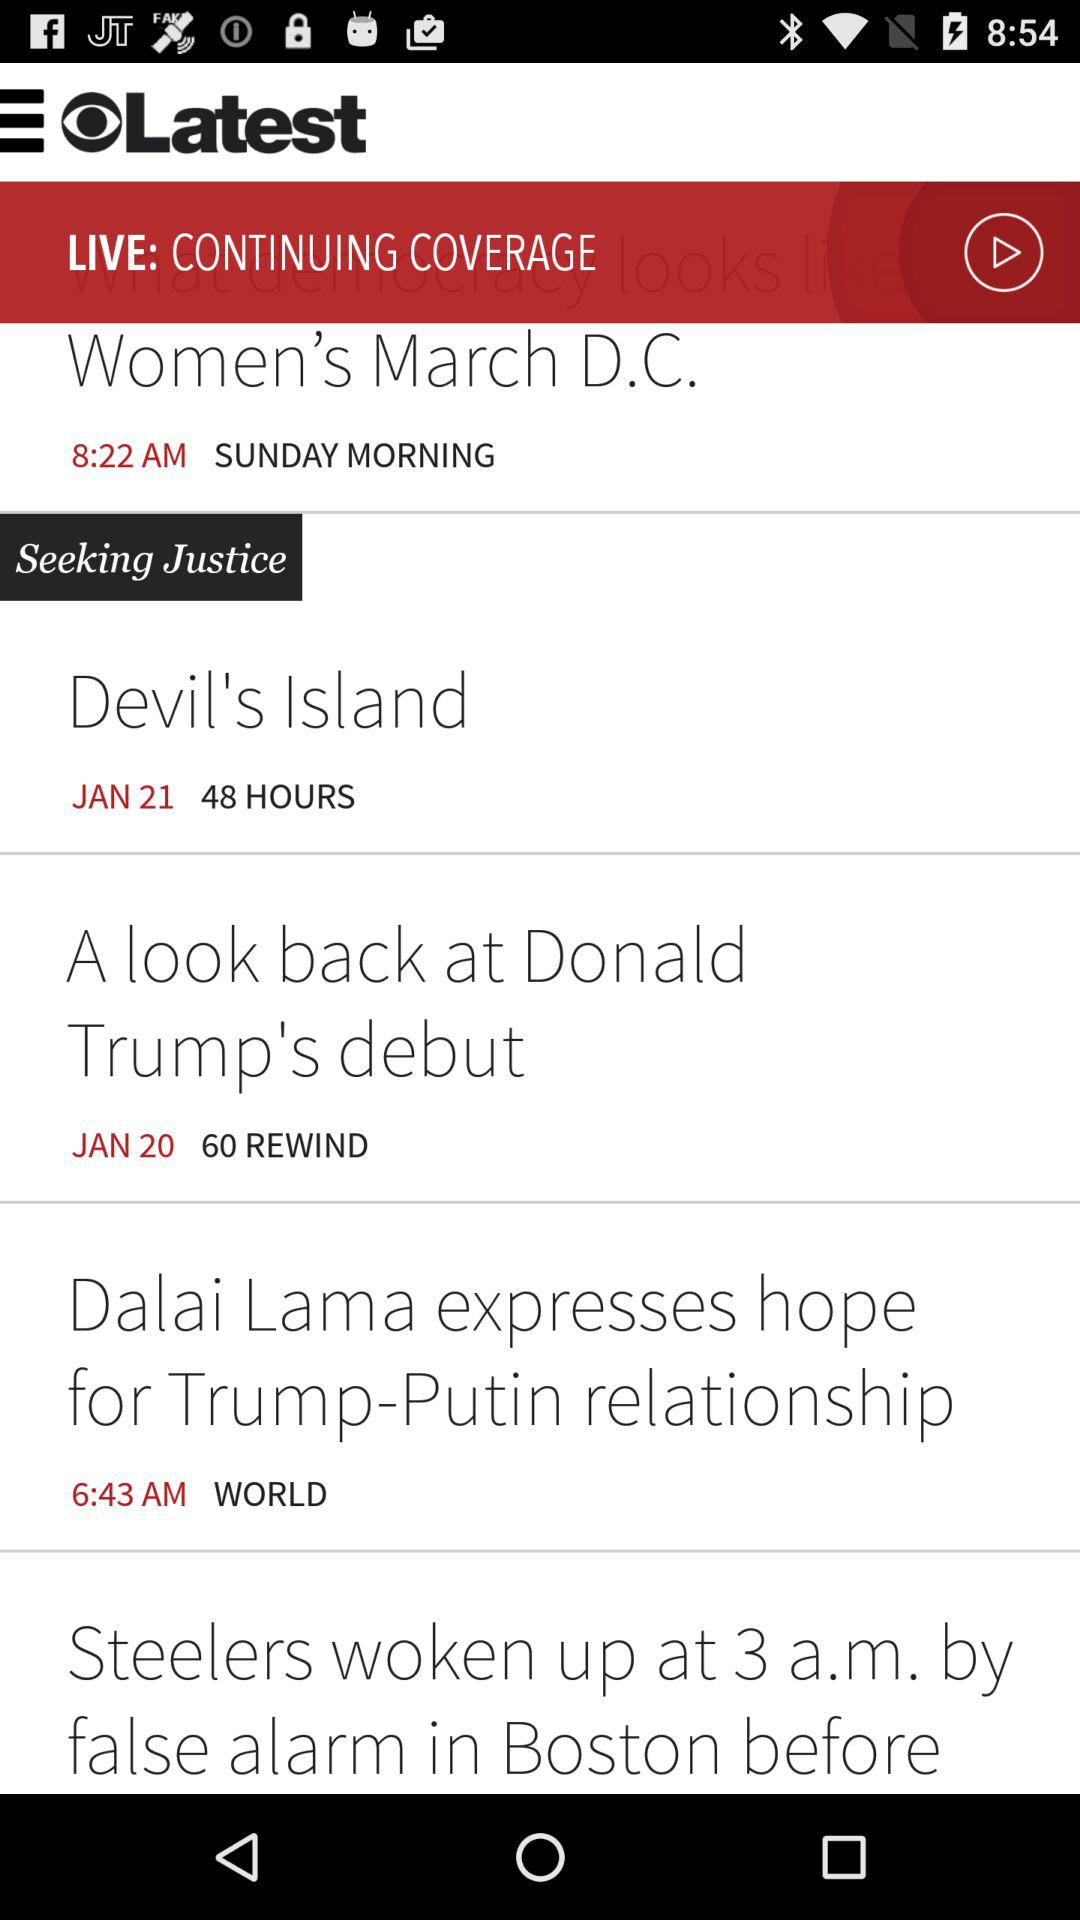What is the year of Devil's island?
When the provided information is insufficient, respond with <no answer>. <no answer> 